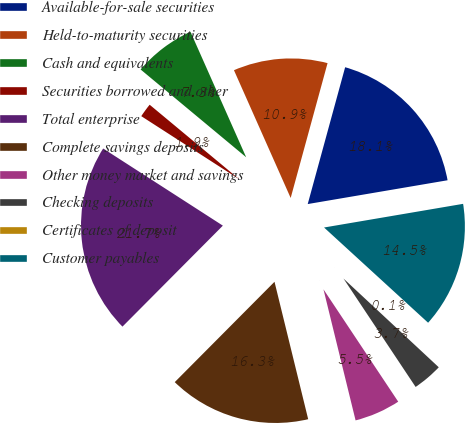<chart> <loc_0><loc_0><loc_500><loc_500><pie_chart><fcel>Available-for-sale securities<fcel>Held-to-maturity securities<fcel>Cash and equivalents<fcel>Securities borrowed and other<fcel>Total enterprise<fcel>Complete savings deposits<fcel>Other money market and savings<fcel>Checking deposits<fcel>Certificates of deposit<fcel>Customer payables<nl><fcel>18.07%<fcel>10.9%<fcel>7.31%<fcel>1.93%<fcel>21.66%<fcel>16.28%<fcel>5.52%<fcel>3.72%<fcel>0.14%<fcel>14.48%<nl></chart> 